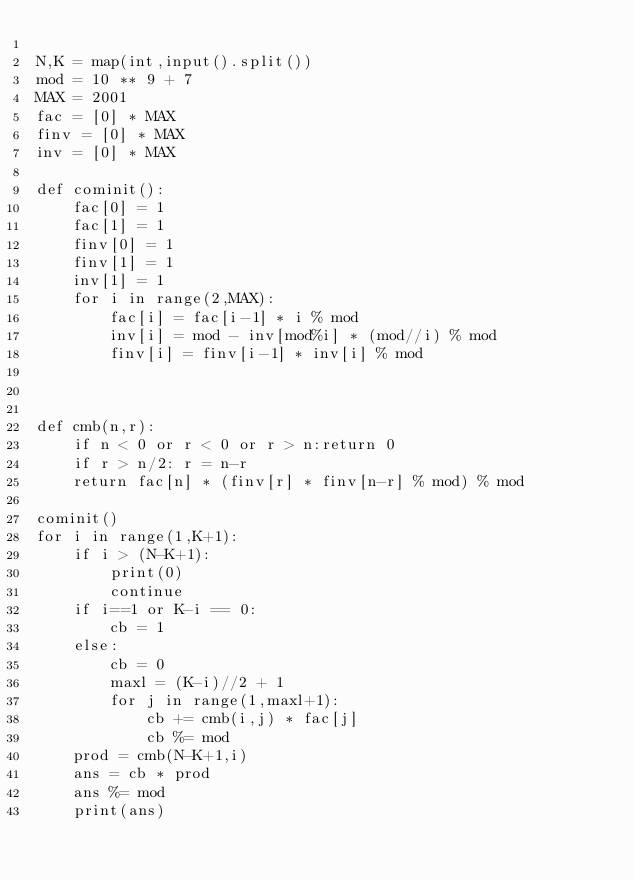<code> <loc_0><loc_0><loc_500><loc_500><_Python_>
N,K = map(int,input().split())
mod = 10 ** 9 + 7
MAX = 2001
fac = [0] * MAX
finv = [0] * MAX
inv = [0] * MAX

def cominit():
    fac[0] = 1
    fac[1] = 1
    finv[0] = 1
    finv[1] = 1
    inv[1] = 1
    for i in range(2,MAX):
        fac[i] = fac[i-1] * i % mod
        inv[i] = mod - inv[mod%i] * (mod//i) % mod
        finv[i] = finv[i-1] * inv[i] % mod



def cmb(n,r):
    if n < 0 or r < 0 or r > n:return 0
    if r > n/2: r = n-r        
    return fac[n] * (finv[r] * finv[n-r] % mod) % mod

cominit()
for i in range(1,K+1):
    if i > (N-K+1):
        print(0)
        continue
    if i==1 or K-i == 0:
        cb = 1
    else:
        cb = 0
        maxl = (K-i)//2 + 1
        for j in range(1,maxl+1):
            cb += cmb(i,j) * fac[j]
            cb %= mod
    prod = cmb(N-K+1,i)
    ans = cb * prod
    ans %= mod
    print(ans)
        </code> 